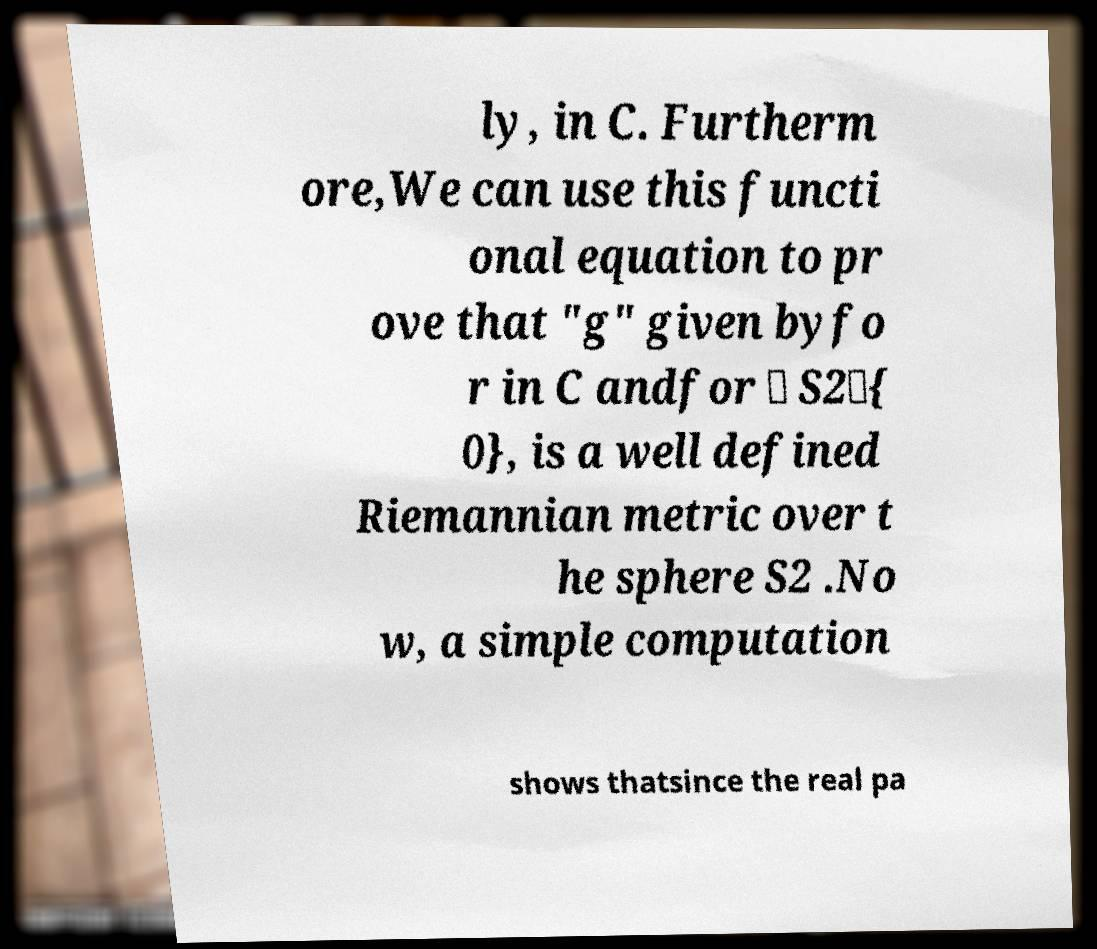There's text embedded in this image that I need extracted. Can you transcribe it verbatim? ly, in C. Furtherm ore,We can use this functi onal equation to pr ove that "g" given byfo r in C andfor ∈ S2\{ 0}, is a well defined Riemannian metric over t he sphere S2 .No w, a simple computation shows thatsince the real pa 